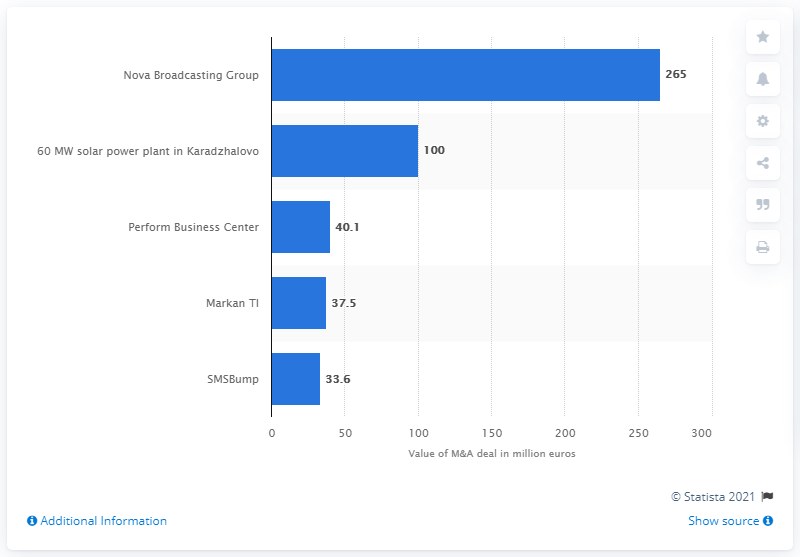Specify some key components in this picture. The total cost of the deal in 2020 was 265... In 2020, the largest mergers and acquisitions transaction in Bulgaria was the acquisition of Nova Broadcasting Group by a private investment firm. The price of the second largest M&A deal in Bulgaria in 2020 was 100... 